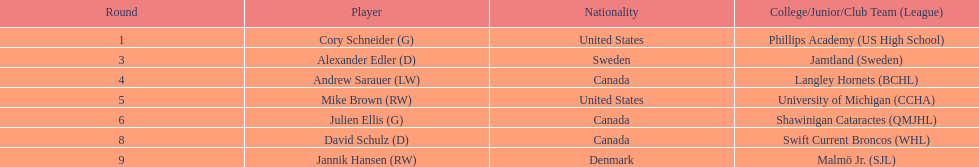Which player was the first player to be drafted? Cory Schneider (G). 